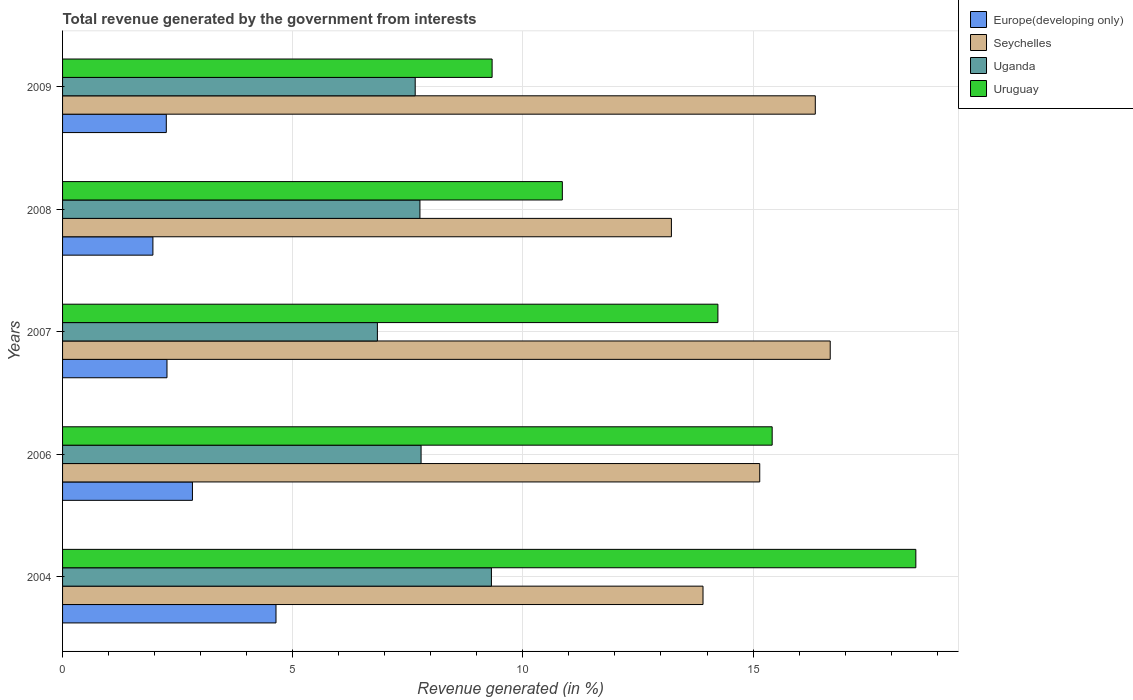How many different coloured bars are there?
Your response must be concise. 4. Are the number of bars per tick equal to the number of legend labels?
Your answer should be very brief. Yes. Are the number of bars on each tick of the Y-axis equal?
Make the answer very short. Yes. How many bars are there on the 1st tick from the top?
Offer a very short reply. 4. What is the total revenue generated in Seychelles in 2009?
Make the answer very short. 16.35. Across all years, what is the maximum total revenue generated in Uruguay?
Ensure brevity in your answer.  18.54. Across all years, what is the minimum total revenue generated in Uganda?
Your answer should be compact. 6.84. In which year was the total revenue generated in Seychelles maximum?
Ensure brevity in your answer.  2007. In which year was the total revenue generated in Uruguay minimum?
Give a very brief answer. 2009. What is the total total revenue generated in Uganda in the graph?
Your answer should be very brief. 39.37. What is the difference between the total revenue generated in Europe(developing only) in 2004 and that in 2008?
Provide a succinct answer. 2.67. What is the difference between the total revenue generated in Seychelles in 2004 and the total revenue generated in Uganda in 2008?
Keep it short and to the point. 6.15. What is the average total revenue generated in Europe(developing only) per year?
Provide a short and direct response. 2.79. In the year 2006, what is the difference between the total revenue generated in Uganda and total revenue generated in Uruguay?
Provide a short and direct response. -7.63. What is the ratio of the total revenue generated in Seychelles in 2004 to that in 2006?
Give a very brief answer. 0.92. Is the total revenue generated in Uruguay in 2008 less than that in 2009?
Your response must be concise. No. Is the difference between the total revenue generated in Uganda in 2006 and 2009 greater than the difference between the total revenue generated in Uruguay in 2006 and 2009?
Provide a succinct answer. No. What is the difference between the highest and the second highest total revenue generated in Uganda?
Provide a succinct answer. 1.53. What is the difference between the highest and the lowest total revenue generated in Uruguay?
Your response must be concise. 9.21. In how many years, is the total revenue generated in Seychelles greater than the average total revenue generated in Seychelles taken over all years?
Give a very brief answer. 3. Is the sum of the total revenue generated in Seychelles in 2008 and 2009 greater than the maximum total revenue generated in Europe(developing only) across all years?
Ensure brevity in your answer.  Yes. What does the 2nd bar from the top in 2006 represents?
Your response must be concise. Uganda. What does the 1st bar from the bottom in 2006 represents?
Offer a terse response. Europe(developing only). How many years are there in the graph?
Your answer should be compact. 5. What is the difference between two consecutive major ticks on the X-axis?
Ensure brevity in your answer.  5. How many legend labels are there?
Your answer should be compact. 4. How are the legend labels stacked?
Your response must be concise. Vertical. What is the title of the graph?
Give a very brief answer. Total revenue generated by the government from interests. Does "Korea (Democratic)" appear as one of the legend labels in the graph?
Offer a terse response. No. What is the label or title of the X-axis?
Offer a very short reply. Revenue generated (in %). What is the label or title of the Y-axis?
Your response must be concise. Years. What is the Revenue generated (in %) of Europe(developing only) in 2004?
Provide a succinct answer. 4.64. What is the Revenue generated (in %) of Seychelles in 2004?
Keep it short and to the point. 13.91. What is the Revenue generated (in %) in Uganda in 2004?
Provide a short and direct response. 9.32. What is the Revenue generated (in %) in Uruguay in 2004?
Your answer should be very brief. 18.54. What is the Revenue generated (in %) of Europe(developing only) in 2006?
Your answer should be compact. 2.82. What is the Revenue generated (in %) in Seychelles in 2006?
Keep it short and to the point. 15.15. What is the Revenue generated (in %) of Uganda in 2006?
Give a very brief answer. 7.79. What is the Revenue generated (in %) of Uruguay in 2006?
Ensure brevity in your answer.  15.42. What is the Revenue generated (in %) of Europe(developing only) in 2007?
Ensure brevity in your answer.  2.27. What is the Revenue generated (in %) in Seychelles in 2007?
Give a very brief answer. 16.68. What is the Revenue generated (in %) in Uganda in 2007?
Offer a terse response. 6.84. What is the Revenue generated (in %) of Uruguay in 2007?
Provide a short and direct response. 14.24. What is the Revenue generated (in %) of Europe(developing only) in 2008?
Your answer should be very brief. 1.96. What is the Revenue generated (in %) in Seychelles in 2008?
Offer a terse response. 13.23. What is the Revenue generated (in %) in Uganda in 2008?
Provide a short and direct response. 7.76. What is the Revenue generated (in %) of Uruguay in 2008?
Your answer should be very brief. 10.86. What is the Revenue generated (in %) in Europe(developing only) in 2009?
Your answer should be very brief. 2.25. What is the Revenue generated (in %) in Seychelles in 2009?
Offer a very short reply. 16.35. What is the Revenue generated (in %) in Uganda in 2009?
Provide a short and direct response. 7.66. What is the Revenue generated (in %) in Uruguay in 2009?
Your answer should be compact. 9.33. Across all years, what is the maximum Revenue generated (in %) in Europe(developing only)?
Your answer should be compact. 4.64. Across all years, what is the maximum Revenue generated (in %) of Seychelles?
Give a very brief answer. 16.68. Across all years, what is the maximum Revenue generated (in %) in Uganda?
Ensure brevity in your answer.  9.32. Across all years, what is the maximum Revenue generated (in %) of Uruguay?
Your response must be concise. 18.54. Across all years, what is the minimum Revenue generated (in %) of Europe(developing only)?
Keep it short and to the point. 1.96. Across all years, what is the minimum Revenue generated (in %) in Seychelles?
Give a very brief answer. 13.23. Across all years, what is the minimum Revenue generated (in %) of Uganda?
Ensure brevity in your answer.  6.84. Across all years, what is the minimum Revenue generated (in %) of Uruguay?
Provide a short and direct response. 9.33. What is the total Revenue generated (in %) in Europe(developing only) in the graph?
Your answer should be very brief. 13.94. What is the total Revenue generated (in %) of Seychelles in the graph?
Your answer should be compact. 75.31. What is the total Revenue generated (in %) of Uganda in the graph?
Make the answer very short. 39.37. What is the total Revenue generated (in %) of Uruguay in the graph?
Give a very brief answer. 68.38. What is the difference between the Revenue generated (in %) of Europe(developing only) in 2004 and that in 2006?
Provide a succinct answer. 1.82. What is the difference between the Revenue generated (in %) in Seychelles in 2004 and that in 2006?
Provide a short and direct response. -1.23. What is the difference between the Revenue generated (in %) of Uganda in 2004 and that in 2006?
Your answer should be very brief. 1.53. What is the difference between the Revenue generated (in %) in Uruguay in 2004 and that in 2006?
Your answer should be very brief. 3.12. What is the difference between the Revenue generated (in %) of Europe(developing only) in 2004 and that in 2007?
Your answer should be compact. 2.37. What is the difference between the Revenue generated (in %) of Seychelles in 2004 and that in 2007?
Offer a very short reply. -2.76. What is the difference between the Revenue generated (in %) of Uganda in 2004 and that in 2007?
Keep it short and to the point. 2.48. What is the difference between the Revenue generated (in %) of Uruguay in 2004 and that in 2007?
Make the answer very short. 4.3. What is the difference between the Revenue generated (in %) of Europe(developing only) in 2004 and that in 2008?
Provide a succinct answer. 2.67. What is the difference between the Revenue generated (in %) in Seychelles in 2004 and that in 2008?
Make the answer very short. 0.69. What is the difference between the Revenue generated (in %) of Uganda in 2004 and that in 2008?
Make the answer very short. 1.55. What is the difference between the Revenue generated (in %) in Uruguay in 2004 and that in 2008?
Provide a succinct answer. 7.68. What is the difference between the Revenue generated (in %) of Europe(developing only) in 2004 and that in 2009?
Your answer should be compact. 2.38. What is the difference between the Revenue generated (in %) of Seychelles in 2004 and that in 2009?
Ensure brevity in your answer.  -2.44. What is the difference between the Revenue generated (in %) of Uganda in 2004 and that in 2009?
Ensure brevity in your answer.  1.66. What is the difference between the Revenue generated (in %) of Uruguay in 2004 and that in 2009?
Your answer should be very brief. 9.21. What is the difference between the Revenue generated (in %) of Europe(developing only) in 2006 and that in 2007?
Keep it short and to the point. 0.55. What is the difference between the Revenue generated (in %) of Seychelles in 2006 and that in 2007?
Give a very brief answer. -1.53. What is the difference between the Revenue generated (in %) in Uganda in 2006 and that in 2007?
Provide a short and direct response. 0.95. What is the difference between the Revenue generated (in %) in Uruguay in 2006 and that in 2007?
Ensure brevity in your answer.  1.18. What is the difference between the Revenue generated (in %) in Europe(developing only) in 2006 and that in 2008?
Offer a very short reply. 0.86. What is the difference between the Revenue generated (in %) of Seychelles in 2006 and that in 2008?
Ensure brevity in your answer.  1.92. What is the difference between the Revenue generated (in %) of Uganda in 2006 and that in 2008?
Keep it short and to the point. 0.02. What is the difference between the Revenue generated (in %) of Uruguay in 2006 and that in 2008?
Give a very brief answer. 4.56. What is the difference between the Revenue generated (in %) in Europe(developing only) in 2006 and that in 2009?
Provide a succinct answer. 0.57. What is the difference between the Revenue generated (in %) of Seychelles in 2006 and that in 2009?
Your answer should be very brief. -1.21. What is the difference between the Revenue generated (in %) in Uganda in 2006 and that in 2009?
Give a very brief answer. 0.13. What is the difference between the Revenue generated (in %) in Uruguay in 2006 and that in 2009?
Give a very brief answer. 6.08. What is the difference between the Revenue generated (in %) in Europe(developing only) in 2007 and that in 2008?
Provide a succinct answer. 0.31. What is the difference between the Revenue generated (in %) in Seychelles in 2007 and that in 2008?
Your answer should be compact. 3.45. What is the difference between the Revenue generated (in %) in Uganda in 2007 and that in 2008?
Your answer should be compact. -0.92. What is the difference between the Revenue generated (in %) of Uruguay in 2007 and that in 2008?
Ensure brevity in your answer.  3.38. What is the difference between the Revenue generated (in %) of Europe(developing only) in 2007 and that in 2009?
Make the answer very short. 0.01. What is the difference between the Revenue generated (in %) of Seychelles in 2007 and that in 2009?
Ensure brevity in your answer.  0.32. What is the difference between the Revenue generated (in %) in Uganda in 2007 and that in 2009?
Provide a short and direct response. -0.82. What is the difference between the Revenue generated (in %) in Uruguay in 2007 and that in 2009?
Ensure brevity in your answer.  4.91. What is the difference between the Revenue generated (in %) of Europe(developing only) in 2008 and that in 2009?
Offer a terse response. -0.29. What is the difference between the Revenue generated (in %) in Seychelles in 2008 and that in 2009?
Your response must be concise. -3.13. What is the difference between the Revenue generated (in %) in Uganda in 2008 and that in 2009?
Ensure brevity in your answer.  0.1. What is the difference between the Revenue generated (in %) in Uruguay in 2008 and that in 2009?
Provide a short and direct response. 1.53. What is the difference between the Revenue generated (in %) in Europe(developing only) in 2004 and the Revenue generated (in %) in Seychelles in 2006?
Your response must be concise. -10.51. What is the difference between the Revenue generated (in %) of Europe(developing only) in 2004 and the Revenue generated (in %) of Uganda in 2006?
Give a very brief answer. -3.15. What is the difference between the Revenue generated (in %) in Europe(developing only) in 2004 and the Revenue generated (in %) in Uruguay in 2006?
Offer a terse response. -10.78. What is the difference between the Revenue generated (in %) of Seychelles in 2004 and the Revenue generated (in %) of Uganda in 2006?
Offer a very short reply. 6.12. What is the difference between the Revenue generated (in %) of Seychelles in 2004 and the Revenue generated (in %) of Uruguay in 2006?
Make the answer very short. -1.5. What is the difference between the Revenue generated (in %) in Uganda in 2004 and the Revenue generated (in %) in Uruguay in 2006?
Make the answer very short. -6.1. What is the difference between the Revenue generated (in %) in Europe(developing only) in 2004 and the Revenue generated (in %) in Seychelles in 2007?
Make the answer very short. -12.04. What is the difference between the Revenue generated (in %) of Europe(developing only) in 2004 and the Revenue generated (in %) of Uganda in 2007?
Your answer should be compact. -2.2. What is the difference between the Revenue generated (in %) of Europe(developing only) in 2004 and the Revenue generated (in %) of Uruguay in 2007?
Your answer should be very brief. -9.6. What is the difference between the Revenue generated (in %) in Seychelles in 2004 and the Revenue generated (in %) in Uganda in 2007?
Provide a succinct answer. 7.07. What is the difference between the Revenue generated (in %) in Seychelles in 2004 and the Revenue generated (in %) in Uruguay in 2007?
Keep it short and to the point. -0.32. What is the difference between the Revenue generated (in %) in Uganda in 2004 and the Revenue generated (in %) in Uruguay in 2007?
Offer a very short reply. -4.92. What is the difference between the Revenue generated (in %) of Europe(developing only) in 2004 and the Revenue generated (in %) of Seychelles in 2008?
Provide a succinct answer. -8.59. What is the difference between the Revenue generated (in %) of Europe(developing only) in 2004 and the Revenue generated (in %) of Uganda in 2008?
Provide a succinct answer. -3.13. What is the difference between the Revenue generated (in %) of Europe(developing only) in 2004 and the Revenue generated (in %) of Uruguay in 2008?
Provide a succinct answer. -6.22. What is the difference between the Revenue generated (in %) in Seychelles in 2004 and the Revenue generated (in %) in Uganda in 2008?
Provide a succinct answer. 6.15. What is the difference between the Revenue generated (in %) in Seychelles in 2004 and the Revenue generated (in %) in Uruguay in 2008?
Your answer should be compact. 3.06. What is the difference between the Revenue generated (in %) in Uganda in 2004 and the Revenue generated (in %) in Uruguay in 2008?
Keep it short and to the point. -1.54. What is the difference between the Revenue generated (in %) of Europe(developing only) in 2004 and the Revenue generated (in %) of Seychelles in 2009?
Ensure brevity in your answer.  -11.72. What is the difference between the Revenue generated (in %) of Europe(developing only) in 2004 and the Revenue generated (in %) of Uganda in 2009?
Offer a terse response. -3.02. What is the difference between the Revenue generated (in %) in Europe(developing only) in 2004 and the Revenue generated (in %) in Uruguay in 2009?
Provide a short and direct response. -4.69. What is the difference between the Revenue generated (in %) of Seychelles in 2004 and the Revenue generated (in %) of Uganda in 2009?
Keep it short and to the point. 6.25. What is the difference between the Revenue generated (in %) in Seychelles in 2004 and the Revenue generated (in %) in Uruguay in 2009?
Provide a succinct answer. 4.58. What is the difference between the Revenue generated (in %) in Uganda in 2004 and the Revenue generated (in %) in Uruguay in 2009?
Provide a succinct answer. -0.01. What is the difference between the Revenue generated (in %) in Europe(developing only) in 2006 and the Revenue generated (in %) in Seychelles in 2007?
Your answer should be compact. -13.86. What is the difference between the Revenue generated (in %) of Europe(developing only) in 2006 and the Revenue generated (in %) of Uganda in 2007?
Your answer should be very brief. -4.02. What is the difference between the Revenue generated (in %) of Europe(developing only) in 2006 and the Revenue generated (in %) of Uruguay in 2007?
Offer a terse response. -11.42. What is the difference between the Revenue generated (in %) in Seychelles in 2006 and the Revenue generated (in %) in Uganda in 2007?
Ensure brevity in your answer.  8.31. What is the difference between the Revenue generated (in %) in Seychelles in 2006 and the Revenue generated (in %) in Uruguay in 2007?
Keep it short and to the point. 0.91. What is the difference between the Revenue generated (in %) in Uganda in 2006 and the Revenue generated (in %) in Uruguay in 2007?
Offer a very short reply. -6.45. What is the difference between the Revenue generated (in %) of Europe(developing only) in 2006 and the Revenue generated (in %) of Seychelles in 2008?
Make the answer very short. -10.41. What is the difference between the Revenue generated (in %) of Europe(developing only) in 2006 and the Revenue generated (in %) of Uganda in 2008?
Give a very brief answer. -4.94. What is the difference between the Revenue generated (in %) in Europe(developing only) in 2006 and the Revenue generated (in %) in Uruguay in 2008?
Make the answer very short. -8.04. What is the difference between the Revenue generated (in %) in Seychelles in 2006 and the Revenue generated (in %) in Uganda in 2008?
Your answer should be very brief. 7.38. What is the difference between the Revenue generated (in %) of Seychelles in 2006 and the Revenue generated (in %) of Uruguay in 2008?
Offer a very short reply. 4.29. What is the difference between the Revenue generated (in %) of Uganda in 2006 and the Revenue generated (in %) of Uruguay in 2008?
Keep it short and to the point. -3.07. What is the difference between the Revenue generated (in %) in Europe(developing only) in 2006 and the Revenue generated (in %) in Seychelles in 2009?
Make the answer very short. -13.53. What is the difference between the Revenue generated (in %) of Europe(developing only) in 2006 and the Revenue generated (in %) of Uganda in 2009?
Your answer should be very brief. -4.84. What is the difference between the Revenue generated (in %) in Europe(developing only) in 2006 and the Revenue generated (in %) in Uruguay in 2009?
Keep it short and to the point. -6.51. What is the difference between the Revenue generated (in %) in Seychelles in 2006 and the Revenue generated (in %) in Uganda in 2009?
Ensure brevity in your answer.  7.48. What is the difference between the Revenue generated (in %) of Seychelles in 2006 and the Revenue generated (in %) of Uruguay in 2009?
Keep it short and to the point. 5.81. What is the difference between the Revenue generated (in %) of Uganda in 2006 and the Revenue generated (in %) of Uruguay in 2009?
Provide a succinct answer. -1.54. What is the difference between the Revenue generated (in %) of Europe(developing only) in 2007 and the Revenue generated (in %) of Seychelles in 2008?
Keep it short and to the point. -10.96. What is the difference between the Revenue generated (in %) of Europe(developing only) in 2007 and the Revenue generated (in %) of Uganda in 2008?
Ensure brevity in your answer.  -5.5. What is the difference between the Revenue generated (in %) of Europe(developing only) in 2007 and the Revenue generated (in %) of Uruguay in 2008?
Provide a short and direct response. -8.59. What is the difference between the Revenue generated (in %) in Seychelles in 2007 and the Revenue generated (in %) in Uganda in 2008?
Provide a succinct answer. 8.91. What is the difference between the Revenue generated (in %) in Seychelles in 2007 and the Revenue generated (in %) in Uruguay in 2008?
Provide a succinct answer. 5.82. What is the difference between the Revenue generated (in %) in Uganda in 2007 and the Revenue generated (in %) in Uruguay in 2008?
Give a very brief answer. -4.02. What is the difference between the Revenue generated (in %) in Europe(developing only) in 2007 and the Revenue generated (in %) in Seychelles in 2009?
Provide a short and direct response. -14.08. What is the difference between the Revenue generated (in %) of Europe(developing only) in 2007 and the Revenue generated (in %) of Uganda in 2009?
Provide a short and direct response. -5.39. What is the difference between the Revenue generated (in %) of Europe(developing only) in 2007 and the Revenue generated (in %) of Uruguay in 2009?
Offer a very short reply. -7.06. What is the difference between the Revenue generated (in %) in Seychelles in 2007 and the Revenue generated (in %) in Uganda in 2009?
Offer a terse response. 9.02. What is the difference between the Revenue generated (in %) of Seychelles in 2007 and the Revenue generated (in %) of Uruguay in 2009?
Make the answer very short. 7.35. What is the difference between the Revenue generated (in %) of Uganda in 2007 and the Revenue generated (in %) of Uruguay in 2009?
Offer a very short reply. -2.49. What is the difference between the Revenue generated (in %) of Europe(developing only) in 2008 and the Revenue generated (in %) of Seychelles in 2009?
Ensure brevity in your answer.  -14.39. What is the difference between the Revenue generated (in %) of Europe(developing only) in 2008 and the Revenue generated (in %) of Uganda in 2009?
Your answer should be very brief. -5.7. What is the difference between the Revenue generated (in %) of Europe(developing only) in 2008 and the Revenue generated (in %) of Uruguay in 2009?
Ensure brevity in your answer.  -7.37. What is the difference between the Revenue generated (in %) in Seychelles in 2008 and the Revenue generated (in %) in Uganda in 2009?
Provide a succinct answer. 5.57. What is the difference between the Revenue generated (in %) of Seychelles in 2008 and the Revenue generated (in %) of Uruguay in 2009?
Your answer should be compact. 3.9. What is the difference between the Revenue generated (in %) of Uganda in 2008 and the Revenue generated (in %) of Uruguay in 2009?
Provide a succinct answer. -1.57. What is the average Revenue generated (in %) in Europe(developing only) per year?
Provide a short and direct response. 2.79. What is the average Revenue generated (in %) in Seychelles per year?
Keep it short and to the point. 15.06. What is the average Revenue generated (in %) of Uganda per year?
Ensure brevity in your answer.  7.87. What is the average Revenue generated (in %) in Uruguay per year?
Your answer should be compact. 13.68. In the year 2004, what is the difference between the Revenue generated (in %) of Europe(developing only) and Revenue generated (in %) of Seychelles?
Your answer should be compact. -9.28. In the year 2004, what is the difference between the Revenue generated (in %) in Europe(developing only) and Revenue generated (in %) in Uganda?
Provide a short and direct response. -4.68. In the year 2004, what is the difference between the Revenue generated (in %) in Europe(developing only) and Revenue generated (in %) in Uruguay?
Ensure brevity in your answer.  -13.9. In the year 2004, what is the difference between the Revenue generated (in %) of Seychelles and Revenue generated (in %) of Uganda?
Offer a very short reply. 4.6. In the year 2004, what is the difference between the Revenue generated (in %) in Seychelles and Revenue generated (in %) in Uruguay?
Your answer should be very brief. -4.62. In the year 2004, what is the difference between the Revenue generated (in %) in Uganda and Revenue generated (in %) in Uruguay?
Make the answer very short. -9.22. In the year 2006, what is the difference between the Revenue generated (in %) of Europe(developing only) and Revenue generated (in %) of Seychelles?
Your response must be concise. -12.32. In the year 2006, what is the difference between the Revenue generated (in %) of Europe(developing only) and Revenue generated (in %) of Uganda?
Your answer should be very brief. -4.97. In the year 2006, what is the difference between the Revenue generated (in %) of Europe(developing only) and Revenue generated (in %) of Uruguay?
Provide a short and direct response. -12.59. In the year 2006, what is the difference between the Revenue generated (in %) of Seychelles and Revenue generated (in %) of Uganda?
Offer a terse response. 7.36. In the year 2006, what is the difference between the Revenue generated (in %) of Seychelles and Revenue generated (in %) of Uruguay?
Offer a very short reply. -0.27. In the year 2006, what is the difference between the Revenue generated (in %) of Uganda and Revenue generated (in %) of Uruguay?
Offer a very short reply. -7.63. In the year 2007, what is the difference between the Revenue generated (in %) of Europe(developing only) and Revenue generated (in %) of Seychelles?
Offer a very short reply. -14.41. In the year 2007, what is the difference between the Revenue generated (in %) of Europe(developing only) and Revenue generated (in %) of Uganda?
Provide a succinct answer. -4.57. In the year 2007, what is the difference between the Revenue generated (in %) of Europe(developing only) and Revenue generated (in %) of Uruguay?
Your answer should be compact. -11.97. In the year 2007, what is the difference between the Revenue generated (in %) of Seychelles and Revenue generated (in %) of Uganda?
Make the answer very short. 9.84. In the year 2007, what is the difference between the Revenue generated (in %) of Seychelles and Revenue generated (in %) of Uruguay?
Ensure brevity in your answer.  2.44. In the year 2007, what is the difference between the Revenue generated (in %) in Uganda and Revenue generated (in %) in Uruguay?
Your answer should be compact. -7.4. In the year 2008, what is the difference between the Revenue generated (in %) in Europe(developing only) and Revenue generated (in %) in Seychelles?
Provide a succinct answer. -11.26. In the year 2008, what is the difference between the Revenue generated (in %) in Europe(developing only) and Revenue generated (in %) in Uganda?
Your answer should be very brief. -5.8. In the year 2008, what is the difference between the Revenue generated (in %) of Europe(developing only) and Revenue generated (in %) of Uruguay?
Provide a succinct answer. -8.89. In the year 2008, what is the difference between the Revenue generated (in %) in Seychelles and Revenue generated (in %) in Uganda?
Your answer should be compact. 5.46. In the year 2008, what is the difference between the Revenue generated (in %) in Seychelles and Revenue generated (in %) in Uruguay?
Make the answer very short. 2.37. In the year 2008, what is the difference between the Revenue generated (in %) of Uganda and Revenue generated (in %) of Uruguay?
Keep it short and to the point. -3.09. In the year 2009, what is the difference between the Revenue generated (in %) in Europe(developing only) and Revenue generated (in %) in Seychelles?
Give a very brief answer. -14.1. In the year 2009, what is the difference between the Revenue generated (in %) of Europe(developing only) and Revenue generated (in %) of Uganda?
Your answer should be very brief. -5.41. In the year 2009, what is the difference between the Revenue generated (in %) of Europe(developing only) and Revenue generated (in %) of Uruguay?
Offer a terse response. -7.08. In the year 2009, what is the difference between the Revenue generated (in %) in Seychelles and Revenue generated (in %) in Uganda?
Keep it short and to the point. 8.69. In the year 2009, what is the difference between the Revenue generated (in %) in Seychelles and Revenue generated (in %) in Uruguay?
Provide a short and direct response. 7.02. In the year 2009, what is the difference between the Revenue generated (in %) of Uganda and Revenue generated (in %) of Uruguay?
Ensure brevity in your answer.  -1.67. What is the ratio of the Revenue generated (in %) of Europe(developing only) in 2004 to that in 2006?
Offer a very short reply. 1.64. What is the ratio of the Revenue generated (in %) in Seychelles in 2004 to that in 2006?
Provide a succinct answer. 0.92. What is the ratio of the Revenue generated (in %) in Uganda in 2004 to that in 2006?
Ensure brevity in your answer.  1.2. What is the ratio of the Revenue generated (in %) in Uruguay in 2004 to that in 2006?
Your response must be concise. 1.2. What is the ratio of the Revenue generated (in %) in Europe(developing only) in 2004 to that in 2007?
Offer a very short reply. 2.04. What is the ratio of the Revenue generated (in %) in Seychelles in 2004 to that in 2007?
Make the answer very short. 0.83. What is the ratio of the Revenue generated (in %) of Uganda in 2004 to that in 2007?
Make the answer very short. 1.36. What is the ratio of the Revenue generated (in %) of Uruguay in 2004 to that in 2007?
Offer a very short reply. 1.3. What is the ratio of the Revenue generated (in %) in Europe(developing only) in 2004 to that in 2008?
Offer a terse response. 2.36. What is the ratio of the Revenue generated (in %) in Seychelles in 2004 to that in 2008?
Your response must be concise. 1.05. What is the ratio of the Revenue generated (in %) of Uganda in 2004 to that in 2008?
Give a very brief answer. 1.2. What is the ratio of the Revenue generated (in %) of Uruguay in 2004 to that in 2008?
Your answer should be compact. 1.71. What is the ratio of the Revenue generated (in %) in Europe(developing only) in 2004 to that in 2009?
Keep it short and to the point. 2.06. What is the ratio of the Revenue generated (in %) in Seychelles in 2004 to that in 2009?
Make the answer very short. 0.85. What is the ratio of the Revenue generated (in %) in Uganda in 2004 to that in 2009?
Offer a terse response. 1.22. What is the ratio of the Revenue generated (in %) in Uruguay in 2004 to that in 2009?
Ensure brevity in your answer.  1.99. What is the ratio of the Revenue generated (in %) of Europe(developing only) in 2006 to that in 2007?
Your answer should be compact. 1.24. What is the ratio of the Revenue generated (in %) in Seychelles in 2006 to that in 2007?
Ensure brevity in your answer.  0.91. What is the ratio of the Revenue generated (in %) in Uganda in 2006 to that in 2007?
Make the answer very short. 1.14. What is the ratio of the Revenue generated (in %) of Uruguay in 2006 to that in 2007?
Provide a succinct answer. 1.08. What is the ratio of the Revenue generated (in %) in Europe(developing only) in 2006 to that in 2008?
Offer a terse response. 1.44. What is the ratio of the Revenue generated (in %) in Seychelles in 2006 to that in 2008?
Ensure brevity in your answer.  1.15. What is the ratio of the Revenue generated (in %) of Uruguay in 2006 to that in 2008?
Ensure brevity in your answer.  1.42. What is the ratio of the Revenue generated (in %) in Europe(developing only) in 2006 to that in 2009?
Your response must be concise. 1.25. What is the ratio of the Revenue generated (in %) in Seychelles in 2006 to that in 2009?
Give a very brief answer. 0.93. What is the ratio of the Revenue generated (in %) in Uganda in 2006 to that in 2009?
Offer a terse response. 1.02. What is the ratio of the Revenue generated (in %) of Uruguay in 2006 to that in 2009?
Your answer should be very brief. 1.65. What is the ratio of the Revenue generated (in %) of Europe(developing only) in 2007 to that in 2008?
Your answer should be compact. 1.16. What is the ratio of the Revenue generated (in %) of Seychelles in 2007 to that in 2008?
Offer a terse response. 1.26. What is the ratio of the Revenue generated (in %) of Uganda in 2007 to that in 2008?
Make the answer very short. 0.88. What is the ratio of the Revenue generated (in %) in Uruguay in 2007 to that in 2008?
Your answer should be very brief. 1.31. What is the ratio of the Revenue generated (in %) of Europe(developing only) in 2007 to that in 2009?
Your answer should be compact. 1.01. What is the ratio of the Revenue generated (in %) in Seychelles in 2007 to that in 2009?
Offer a terse response. 1.02. What is the ratio of the Revenue generated (in %) in Uganda in 2007 to that in 2009?
Ensure brevity in your answer.  0.89. What is the ratio of the Revenue generated (in %) of Uruguay in 2007 to that in 2009?
Your response must be concise. 1.53. What is the ratio of the Revenue generated (in %) in Europe(developing only) in 2008 to that in 2009?
Ensure brevity in your answer.  0.87. What is the ratio of the Revenue generated (in %) of Seychelles in 2008 to that in 2009?
Keep it short and to the point. 0.81. What is the ratio of the Revenue generated (in %) of Uganda in 2008 to that in 2009?
Your response must be concise. 1.01. What is the ratio of the Revenue generated (in %) of Uruguay in 2008 to that in 2009?
Give a very brief answer. 1.16. What is the difference between the highest and the second highest Revenue generated (in %) of Europe(developing only)?
Your response must be concise. 1.82. What is the difference between the highest and the second highest Revenue generated (in %) in Seychelles?
Offer a terse response. 0.32. What is the difference between the highest and the second highest Revenue generated (in %) in Uganda?
Give a very brief answer. 1.53. What is the difference between the highest and the second highest Revenue generated (in %) of Uruguay?
Offer a very short reply. 3.12. What is the difference between the highest and the lowest Revenue generated (in %) of Europe(developing only)?
Provide a short and direct response. 2.67. What is the difference between the highest and the lowest Revenue generated (in %) of Seychelles?
Provide a succinct answer. 3.45. What is the difference between the highest and the lowest Revenue generated (in %) of Uganda?
Provide a short and direct response. 2.48. What is the difference between the highest and the lowest Revenue generated (in %) of Uruguay?
Provide a succinct answer. 9.21. 